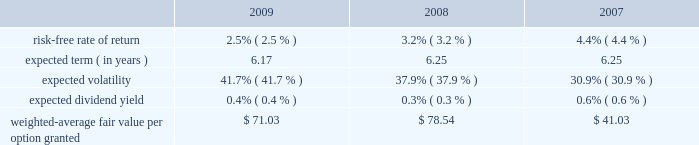Mastercard incorporated notes to consolidated financial statements 2014 ( continued ) ( in thousands , except percent and per share data ) upon termination of employment , excluding retirement , all of a participant 2019s unvested awards are forfeited .
However , when a participant terminates employment due to retirement , the participant generally retains all of their awards without providing additional service to the company .
Eligible retirement is dependent upon age and years of service , as follows : age 55 with ten years of service , age 60 with five years of service and age 65 with two years of service .
Compensation expense is recognized over the shorter of the vesting periods stated in the ltip , or the date the individual becomes eligible to retire .
There are 11550 shares of class a common stock reserved for equity awards under the ltip .
Although the ltip permits the issuance of shares of class b common stock , no such shares have been reserved for issuance .
Shares issued as a result of option exercises and the conversions of rsus are expected to be funded with the issuance of new shares of class a common stock .
Stock options the fair value of each option is estimated on the date of grant using a black-scholes option pricing model .
The table presents the weighted-average assumptions used in the valuation and the resulting weighted- average fair value per option granted for the years ended december 31: .
The risk-free rate of return was based on the u.s .
Treasury yield curve in effect on the date of grant .
The company utilizes the simplified method for calculating the expected term of the option based on the vesting terms and the contractual life of the option .
The expected volatility for options granted during 2009 was based on the average of the implied volatility of mastercard and a blend of the historical volatility of mastercard and the historical volatility of a group of companies that management believes is generally comparable to mastercard .
The expected volatility for options granted during 2008 was based on the average of the implied volatility of mastercard and the historical volatility of a group of companies that management believes is generally comparable to mastercard .
As the company did not have sufficient publicly traded stock data historically , the expected volatility for options granted during 2007 was primarily based on the average of the historical and implied volatility of a group of companies that management believed was generally comparable to mastercard .
The expected dividend yields were based on the company 2019s expected annual dividend rate on the date of grant. .
What was the percent of the change in the risk-free rate of return from 2008 to 2009? 
Computations: ((2.5 - 3.2) / 3.2)
Answer: -0.21875. 